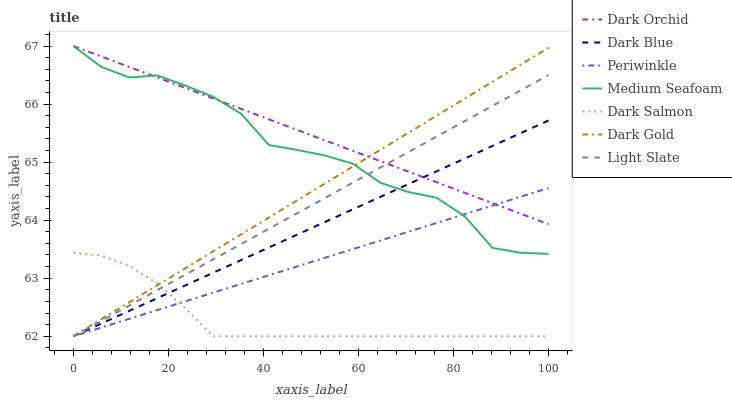Does Dark Salmon have the minimum area under the curve?
Answer yes or no. Yes. Does Dark Orchid have the maximum area under the curve?
Answer yes or no. Yes. Does Light Slate have the minimum area under the curve?
Answer yes or no. No. Does Light Slate have the maximum area under the curve?
Answer yes or no. No. Is Periwinkle the smoothest?
Answer yes or no. Yes. Is Medium Seafoam the roughest?
Answer yes or no. Yes. Is Light Slate the smoothest?
Answer yes or no. No. Is Light Slate the roughest?
Answer yes or no. No. Does Dark Gold have the lowest value?
Answer yes or no. Yes. Does Dark Orchid have the lowest value?
Answer yes or no. No. Does Medium Seafoam have the highest value?
Answer yes or no. Yes. Does Light Slate have the highest value?
Answer yes or no. No. Is Dark Salmon less than Medium Seafoam?
Answer yes or no. Yes. Is Medium Seafoam greater than Dark Salmon?
Answer yes or no. Yes. Does Light Slate intersect Periwinkle?
Answer yes or no. Yes. Is Light Slate less than Periwinkle?
Answer yes or no. No. Is Light Slate greater than Periwinkle?
Answer yes or no. No. Does Dark Salmon intersect Medium Seafoam?
Answer yes or no. No. 